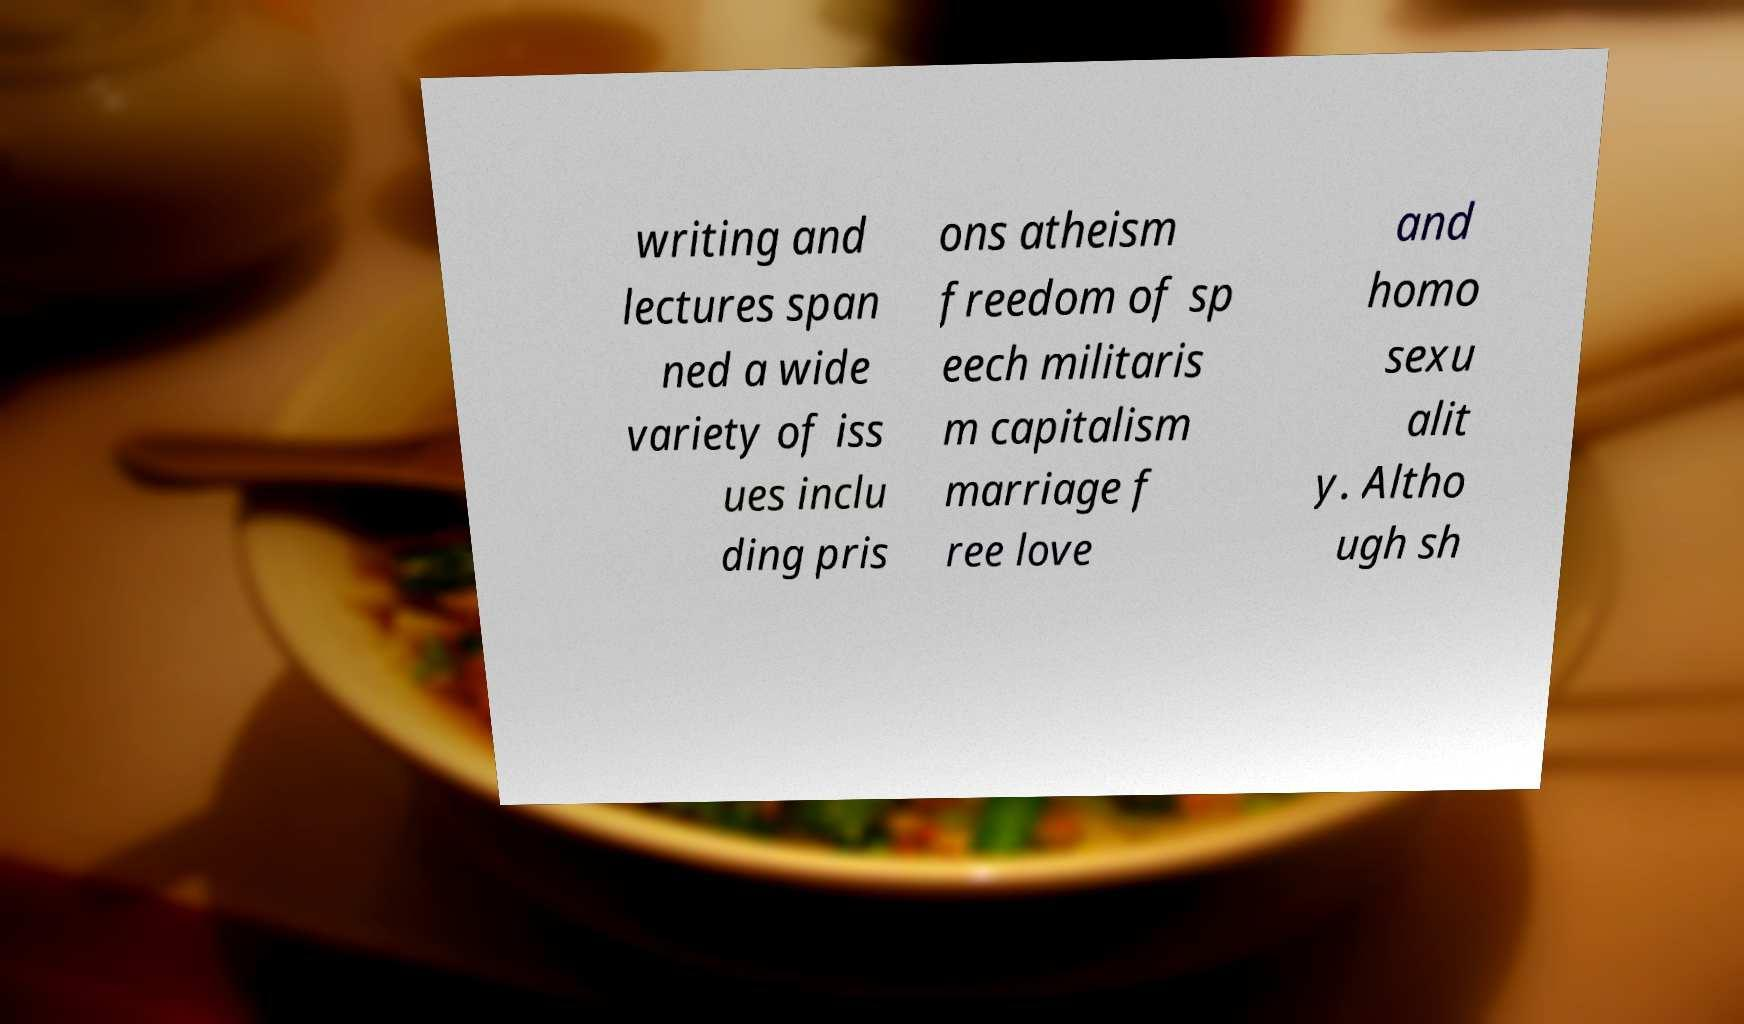Could you assist in decoding the text presented in this image and type it out clearly? writing and lectures span ned a wide variety of iss ues inclu ding pris ons atheism freedom of sp eech militaris m capitalism marriage f ree love and homo sexu alit y. Altho ugh sh 